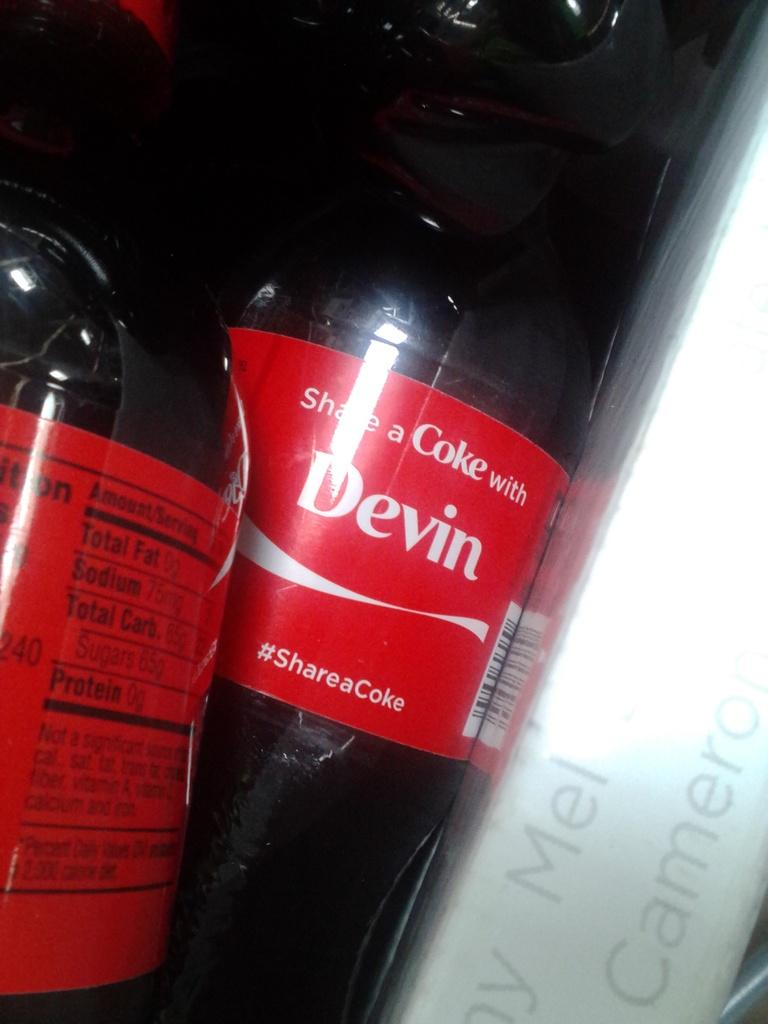<image>
Summarize the visual content of the image. A red label on a bottle tells us to share a Coke with Devin. 